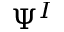<formula> <loc_0><loc_0><loc_500><loc_500>\Psi ^ { I }</formula> 